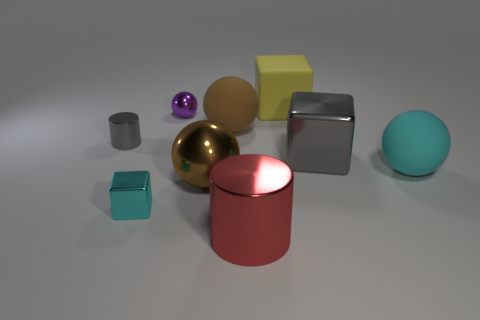There is a brown metal thing that is the same size as the red cylinder; what is its shape? The object you're referring to appears to be a gold-colored sphere, not brown. The sphere is smooth and shiny, reflecting the environment around it. This geometric shape is characterized by a perfectly round three-dimensional form, where all points on the surface are equidistant from the center. 